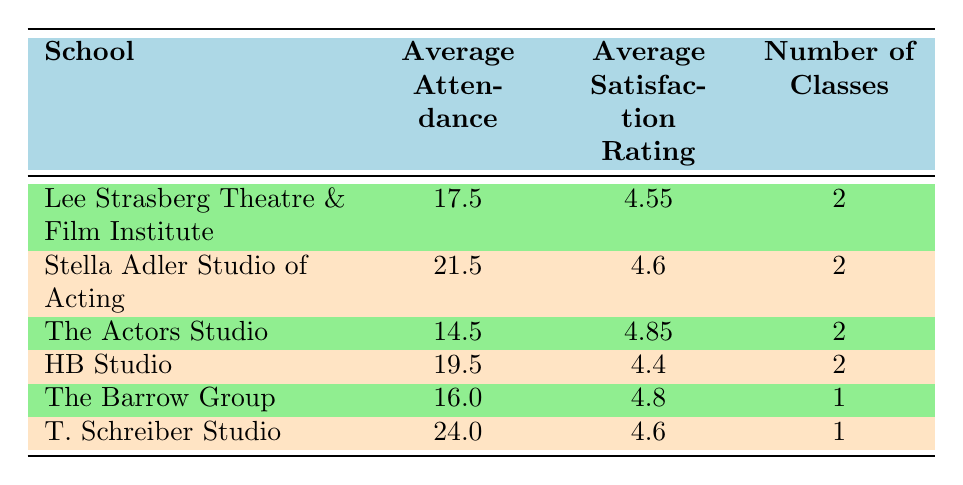What is the average attendance at the Stella Adler Studio of Acting? The average attendance for the Stella Adler Studio of Acting is calculated by looking at its classes: Script Analysis (22) and Character Development (21). The sum is 22 + 21 = 43, and there are 2 classes, so the average is 43 / 2 = 21.5.
Answer: 21.5 Which school has the highest average satisfaction rating? By reviewing the average satisfaction ratings in the table, The Actors Studio has the highest rating at 4.85.
Answer: The Actors Studio What is the total number of classes offered across all schools? To find the total number of classes offered, we sum up the number of classes from each school. Lee Strasberg Theatre (2) + Stella Adler Studio (2) + The Actors Studio (2) + HB Studio (2) + The Barrow Group (1) + T. Schreiber Studio (1) gives us a total of 2 + 2 + 2 + 2 + 1 + 1 = 10 classes.
Answer: 10 Is the average attendance at T. Schreiber Studio higher than that of The Barrow Group? The average attendance for T. Schreiber Studio is 24, while for The Barrow Group it is 16. Since 24 is greater than 16, the average attendance at T. Schreiber Studio is indeed higher.
Answer: Yes What is the difference in average attendance between HB Studio and The Actors Studio? The average attendance at HB Studio is 19.5 and at The Actors Studio is 14.5. To calculate the difference, we subtract the lower average (14.5) from the higher one (19.5): 19.5 - 14.5 = 5.
Answer: 5 